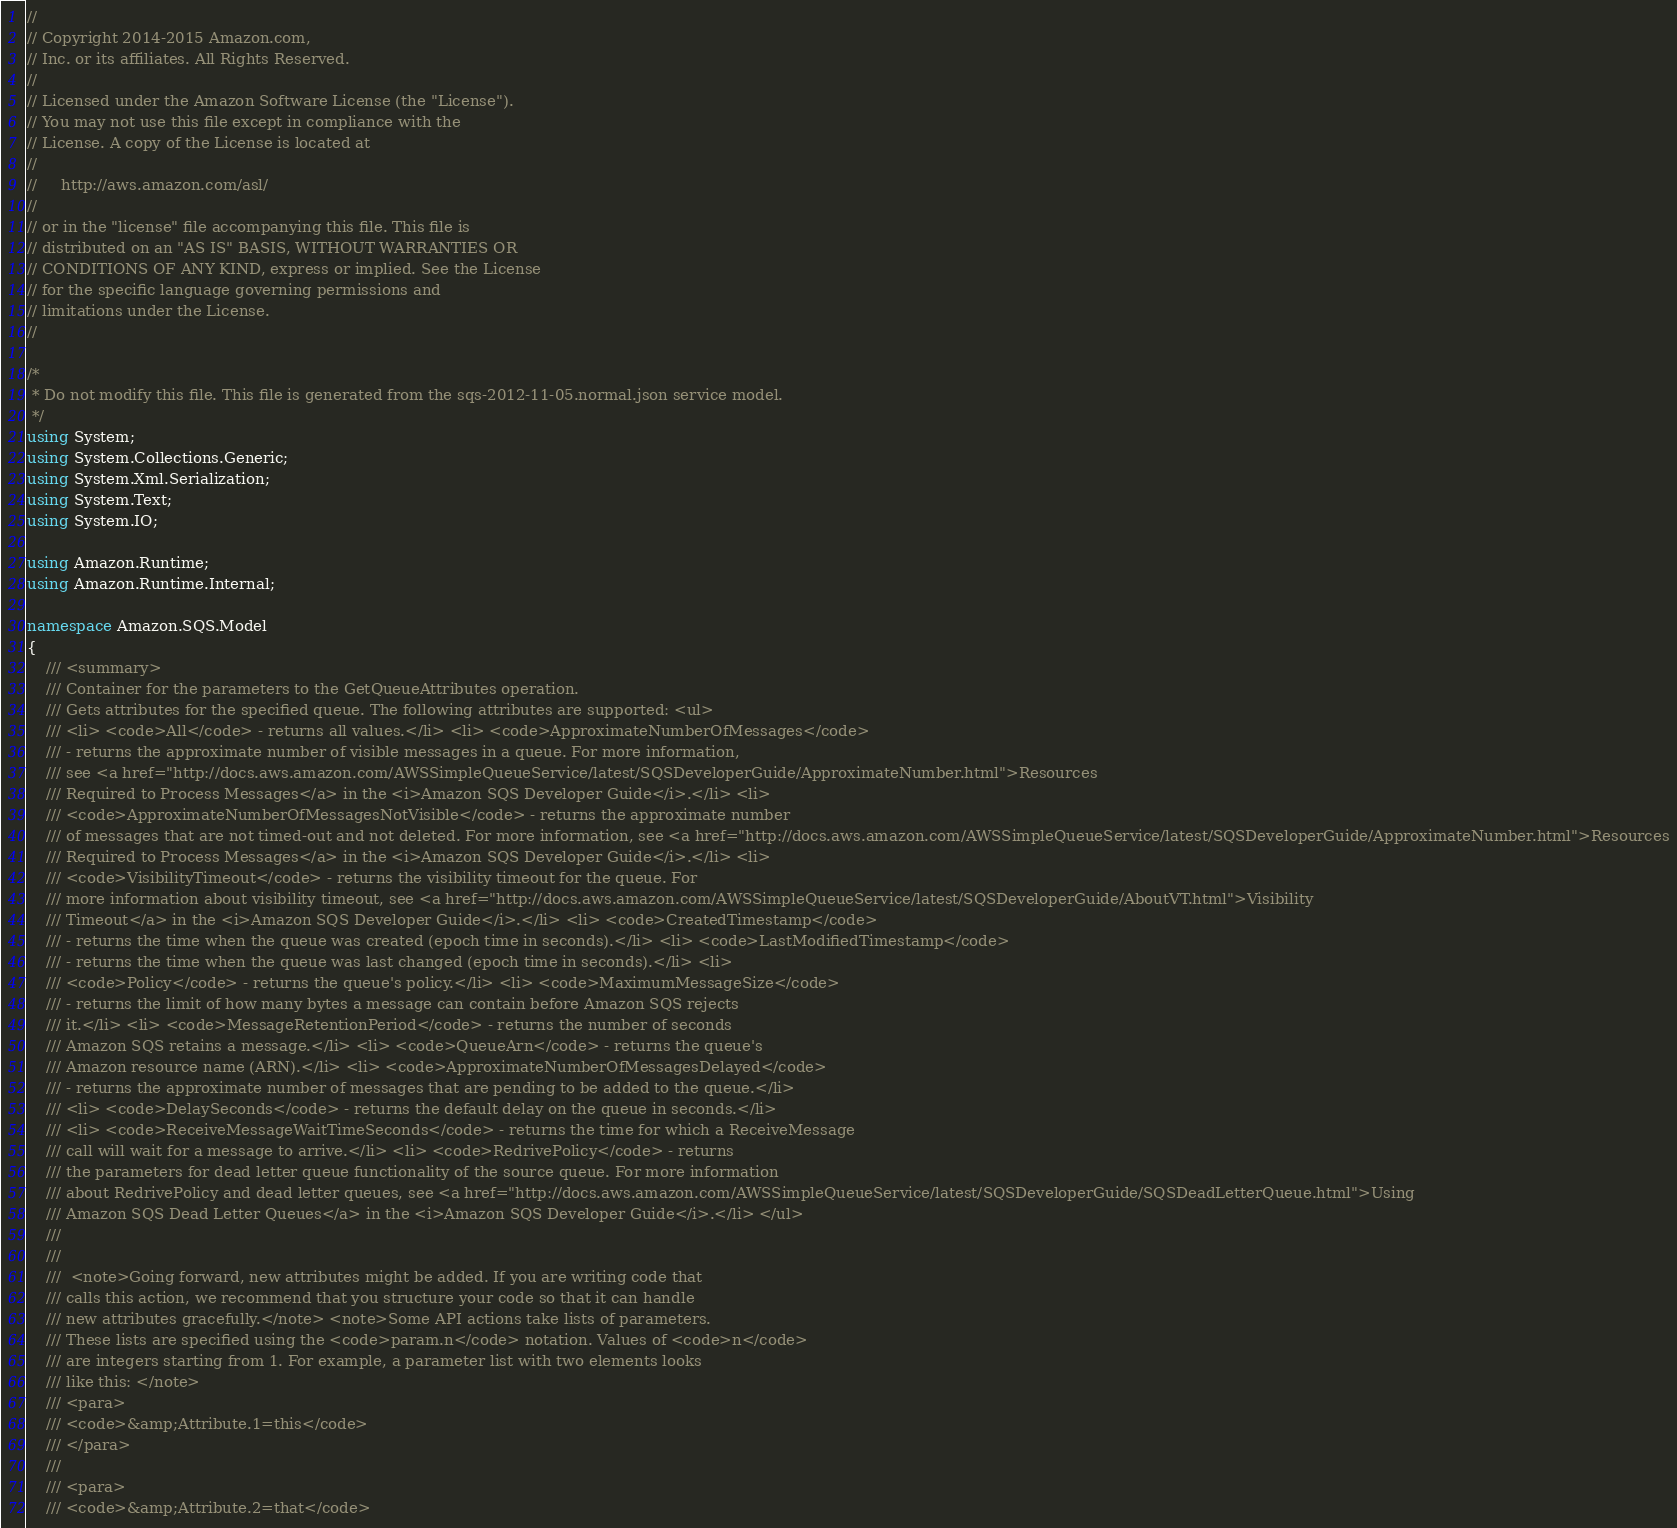<code> <loc_0><loc_0><loc_500><loc_500><_C#_>//
// Copyright 2014-2015 Amazon.com, 
// Inc. or its affiliates. All Rights Reserved.
// 
// Licensed under the Amazon Software License (the "License"). 
// You may not use this file except in compliance with the 
// License. A copy of the License is located at
// 
//     http://aws.amazon.com/asl/
// 
// or in the "license" file accompanying this file. This file is 
// distributed on an "AS IS" BASIS, WITHOUT WARRANTIES OR 
// CONDITIONS OF ANY KIND, express or implied. See the License 
// for the specific language governing permissions and 
// limitations under the License.
//

/*
 * Do not modify this file. This file is generated from the sqs-2012-11-05.normal.json service model.
 */
using System;
using System.Collections.Generic;
using System.Xml.Serialization;
using System.Text;
using System.IO;

using Amazon.Runtime;
using Amazon.Runtime.Internal;

namespace Amazon.SQS.Model
{
    /// <summary>
    /// Container for the parameters to the GetQueueAttributes operation.
    /// Gets attributes for the specified queue. The following attributes are supported: <ul>
    /// <li> <code>All</code> - returns all values.</li> <li> <code>ApproximateNumberOfMessages</code>
    /// - returns the approximate number of visible messages in a queue. For more information,
    /// see <a href="http://docs.aws.amazon.com/AWSSimpleQueueService/latest/SQSDeveloperGuide/ApproximateNumber.html">Resources
    /// Required to Process Messages</a> in the <i>Amazon SQS Developer Guide</i>.</li> <li>
    /// <code>ApproximateNumberOfMessagesNotVisible</code> - returns the approximate number
    /// of messages that are not timed-out and not deleted. For more information, see <a href="http://docs.aws.amazon.com/AWSSimpleQueueService/latest/SQSDeveloperGuide/ApproximateNumber.html">Resources
    /// Required to Process Messages</a> in the <i>Amazon SQS Developer Guide</i>.</li> <li>
    /// <code>VisibilityTimeout</code> - returns the visibility timeout for the queue. For
    /// more information about visibility timeout, see <a href="http://docs.aws.amazon.com/AWSSimpleQueueService/latest/SQSDeveloperGuide/AboutVT.html">Visibility
    /// Timeout</a> in the <i>Amazon SQS Developer Guide</i>.</li> <li> <code>CreatedTimestamp</code>
    /// - returns the time when the queue was created (epoch time in seconds).</li> <li> <code>LastModifiedTimestamp</code>
    /// - returns the time when the queue was last changed (epoch time in seconds).</li> <li>
    /// <code>Policy</code> - returns the queue's policy.</li> <li> <code>MaximumMessageSize</code>
    /// - returns the limit of how many bytes a message can contain before Amazon SQS rejects
    /// it.</li> <li> <code>MessageRetentionPeriod</code> - returns the number of seconds
    /// Amazon SQS retains a message.</li> <li> <code>QueueArn</code> - returns the queue's
    /// Amazon resource name (ARN).</li> <li> <code>ApproximateNumberOfMessagesDelayed</code>
    /// - returns the approximate number of messages that are pending to be added to the queue.</li>
    /// <li> <code>DelaySeconds</code> - returns the default delay on the queue in seconds.</li>
    /// <li> <code>ReceiveMessageWaitTimeSeconds</code> - returns the time for which a ReceiveMessage
    /// call will wait for a message to arrive.</li> <li> <code>RedrivePolicy</code> - returns
    /// the parameters for dead letter queue functionality of the source queue. For more information
    /// about RedrivePolicy and dead letter queues, see <a href="http://docs.aws.amazon.com/AWSSimpleQueueService/latest/SQSDeveloperGuide/SQSDeadLetterQueue.html">Using
    /// Amazon SQS Dead Letter Queues</a> in the <i>Amazon SQS Developer Guide</i>.</li> </ul>
    /// 
    /// 
    ///  <note>Going forward, new attributes might be added. If you are writing code that
    /// calls this action, we recommend that you structure your code so that it can handle
    /// new attributes gracefully.</note> <note>Some API actions take lists of parameters.
    /// These lists are specified using the <code>param.n</code> notation. Values of <code>n</code>
    /// are integers starting from 1. For example, a parameter list with two elements looks
    /// like this: </note> 
    /// <para>
    /// <code>&amp;Attribute.1=this</code>
    /// </para>
    ///  
    /// <para>
    /// <code>&amp;Attribute.2=that</code></code> 